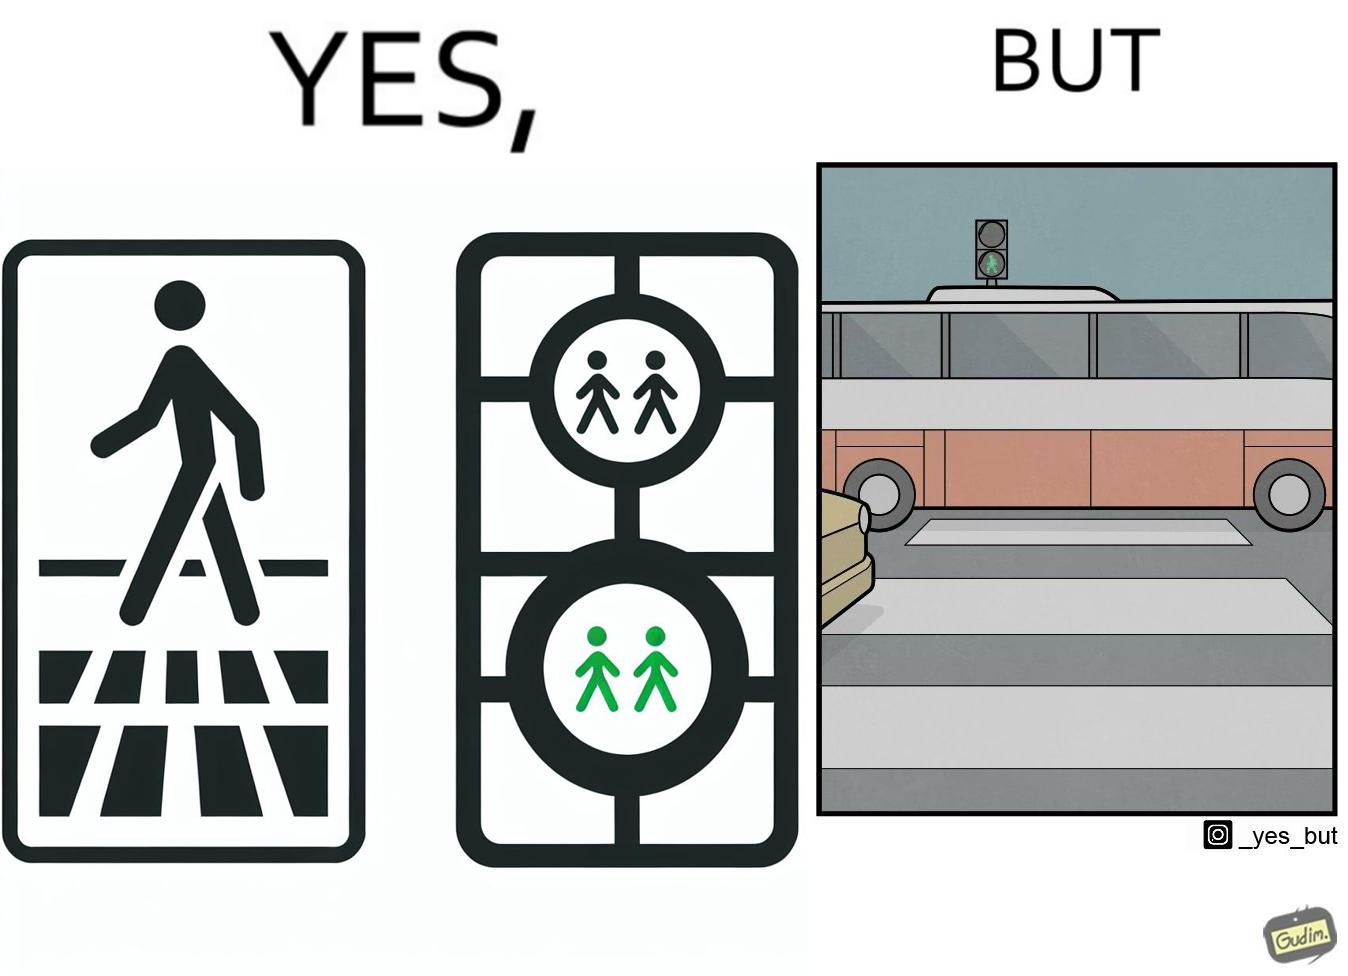Describe what you see in this image. The image is ironic, because even when the signal is green for the pedestrians but they can't cross the road because of the vehicles standing on the zebra crossing 